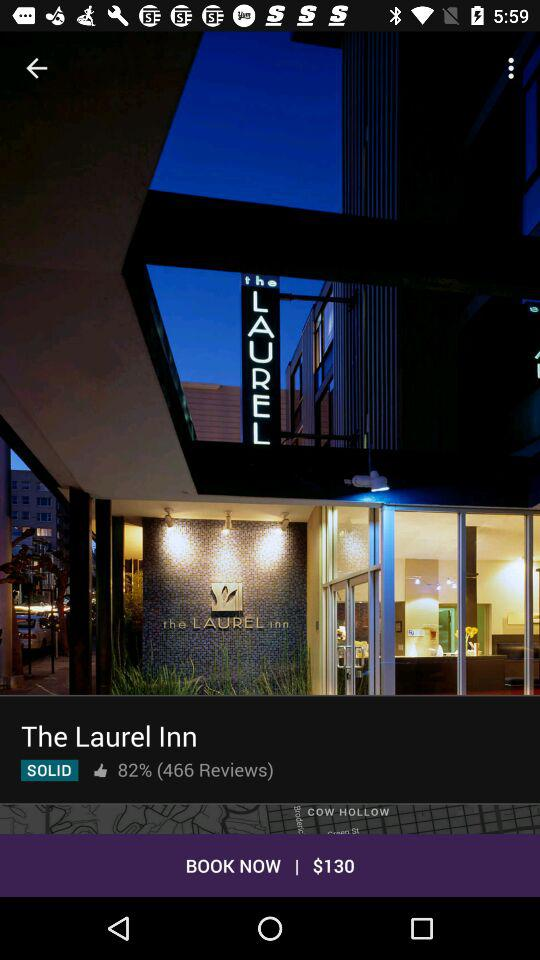How many people have liked? The post was liked by 82% of people. 